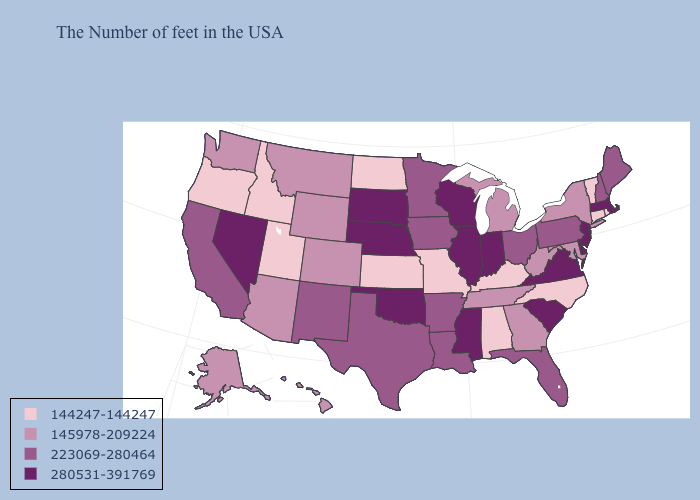Name the states that have a value in the range 144247-144247?
Short answer required. Rhode Island, Vermont, Connecticut, North Carolina, Kentucky, Alabama, Missouri, Kansas, North Dakota, Utah, Idaho, Oregon. What is the value of Idaho?
Short answer required. 144247-144247. Does the map have missing data?
Be succinct. No. Which states have the highest value in the USA?
Quick response, please. Massachusetts, New Jersey, Delaware, Virginia, South Carolina, Indiana, Wisconsin, Illinois, Mississippi, Nebraska, Oklahoma, South Dakota, Nevada. Name the states that have a value in the range 280531-391769?
Answer briefly. Massachusetts, New Jersey, Delaware, Virginia, South Carolina, Indiana, Wisconsin, Illinois, Mississippi, Nebraska, Oklahoma, South Dakota, Nevada. What is the highest value in the MidWest ?
Short answer required. 280531-391769. What is the value of Maryland?
Be succinct. 145978-209224. Name the states that have a value in the range 280531-391769?
Quick response, please. Massachusetts, New Jersey, Delaware, Virginia, South Carolina, Indiana, Wisconsin, Illinois, Mississippi, Nebraska, Oklahoma, South Dakota, Nevada. What is the highest value in the West ?
Short answer required. 280531-391769. What is the lowest value in the Northeast?
Answer briefly. 144247-144247. What is the value of Virginia?
Short answer required. 280531-391769. Name the states that have a value in the range 144247-144247?
Keep it brief. Rhode Island, Vermont, Connecticut, North Carolina, Kentucky, Alabama, Missouri, Kansas, North Dakota, Utah, Idaho, Oregon. Name the states that have a value in the range 145978-209224?
Be succinct. New York, Maryland, West Virginia, Georgia, Michigan, Tennessee, Wyoming, Colorado, Montana, Arizona, Washington, Alaska, Hawaii. What is the value of Oklahoma?
Be succinct. 280531-391769. Does Alabama have the highest value in the USA?
Keep it brief. No. 